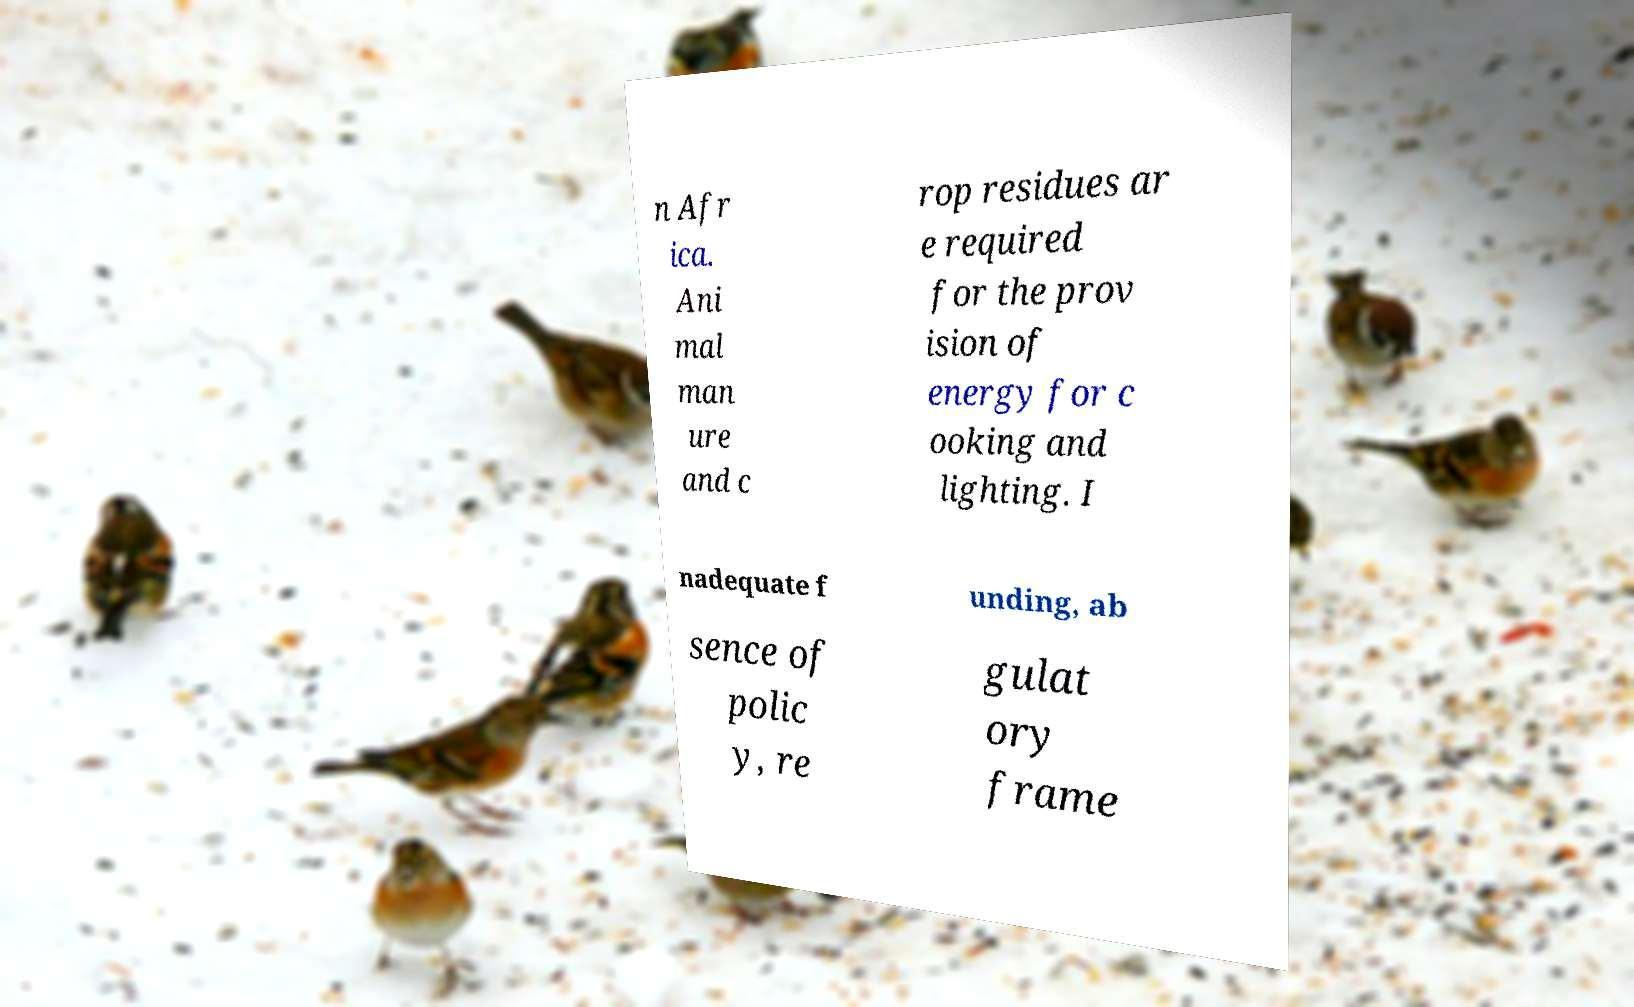Please read and relay the text visible in this image. What does it say? n Afr ica. Ani mal man ure and c rop residues ar e required for the prov ision of energy for c ooking and lighting. I nadequate f unding, ab sence of polic y, re gulat ory frame 